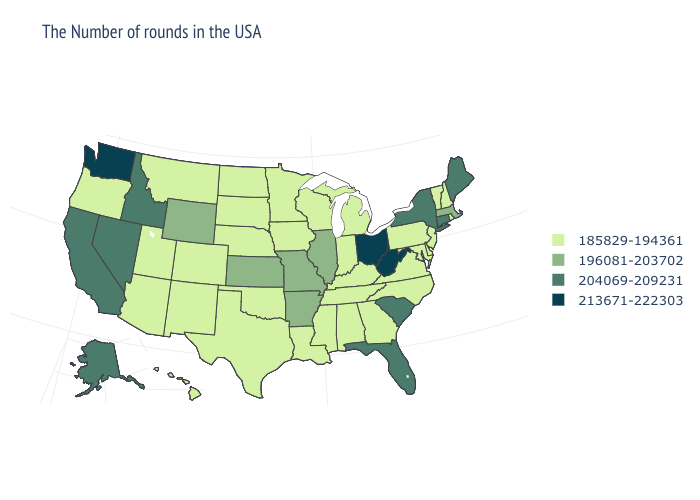Does Ohio have the highest value in the MidWest?
Answer briefly. Yes. Name the states that have a value in the range 204069-209231?
Short answer required. Maine, Connecticut, New York, South Carolina, Florida, Idaho, Nevada, California, Alaska. What is the highest value in the USA?
Quick response, please. 213671-222303. What is the lowest value in the South?
Give a very brief answer. 185829-194361. What is the highest value in states that border South Carolina?
Quick response, please. 185829-194361. Name the states that have a value in the range 213671-222303?
Give a very brief answer. West Virginia, Ohio, Washington. What is the value of Delaware?
Keep it brief. 185829-194361. What is the value of Massachusetts?
Write a very short answer. 196081-203702. Does Utah have a lower value than Illinois?
Give a very brief answer. Yes. Does Arizona have the highest value in the West?
Quick response, please. No. What is the lowest value in the USA?
Answer briefly. 185829-194361. Name the states that have a value in the range 204069-209231?
Concise answer only. Maine, Connecticut, New York, South Carolina, Florida, Idaho, Nevada, California, Alaska. Among the states that border California , does Oregon have the lowest value?
Give a very brief answer. Yes. What is the value of South Dakota?
Keep it brief. 185829-194361. 